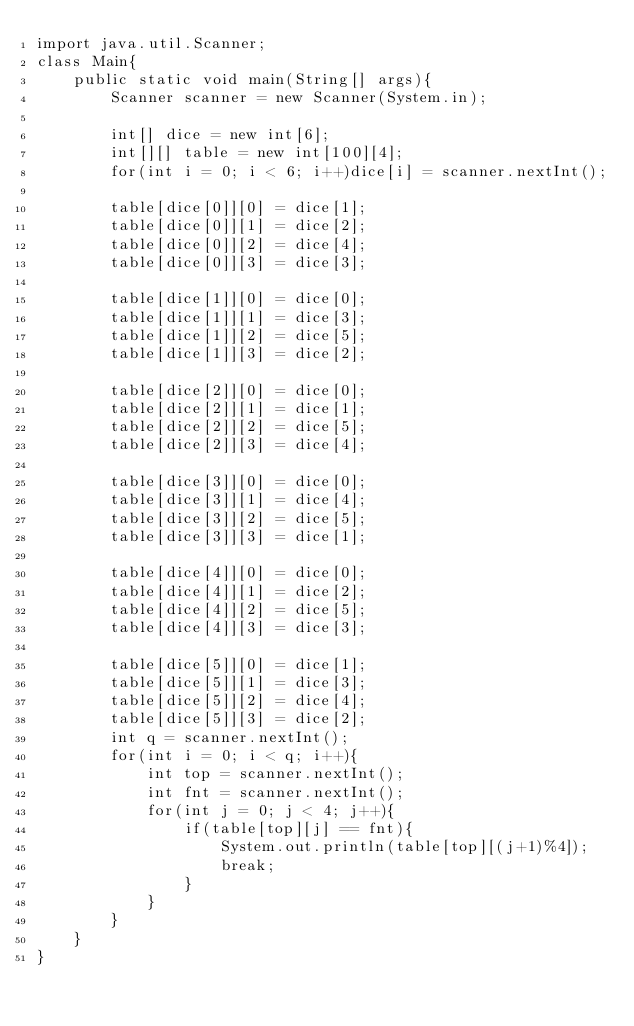Convert code to text. <code><loc_0><loc_0><loc_500><loc_500><_Java_>import java.util.Scanner;
class Main{
    public static void main(String[] args){
        Scanner scanner = new Scanner(System.in);

        int[] dice = new int[6];
        int[][] table = new int[100][4];
        for(int i = 0; i < 6; i++)dice[i] = scanner.nextInt();

        table[dice[0]][0] = dice[1];
        table[dice[0]][1] = dice[2];
        table[dice[0]][2] = dice[4];
        table[dice[0]][3] = dice[3];

        table[dice[1]][0] = dice[0];
        table[dice[1]][1] = dice[3];
        table[dice[1]][2] = dice[5];
        table[dice[1]][3] = dice[2];

        table[dice[2]][0] = dice[0];
        table[dice[2]][1] = dice[1];
        table[dice[2]][2] = dice[5];
        table[dice[2]][3] = dice[4];

        table[dice[3]][0] = dice[0];
        table[dice[3]][1] = dice[4];
        table[dice[3]][2] = dice[5];
        table[dice[3]][3] = dice[1];

        table[dice[4]][0] = dice[0];
        table[dice[4]][1] = dice[2];
        table[dice[4]][2] = dice[5];
        table[dice[4]][3] = dice[3];

        table[dice[5]][0] = dice[1];
        table[dice[5]][1] = dice[3];
        table[dice[5]][2] = dice[4];
        table[dice[5]][3] = dice[2];
        int q = scanner.nextInt();
        for(int i = 0; i < q; i++){
            int top = scanner.nextInt();
            int fnt = scanner.nextInt();
            for(int j = 0; j < 4; j++){
                if(table[top][j] == fnt){
                    System.out.println(table[top][(j+1)%4]);
                    break;
                }
            }
        }
    }
}
</code> 